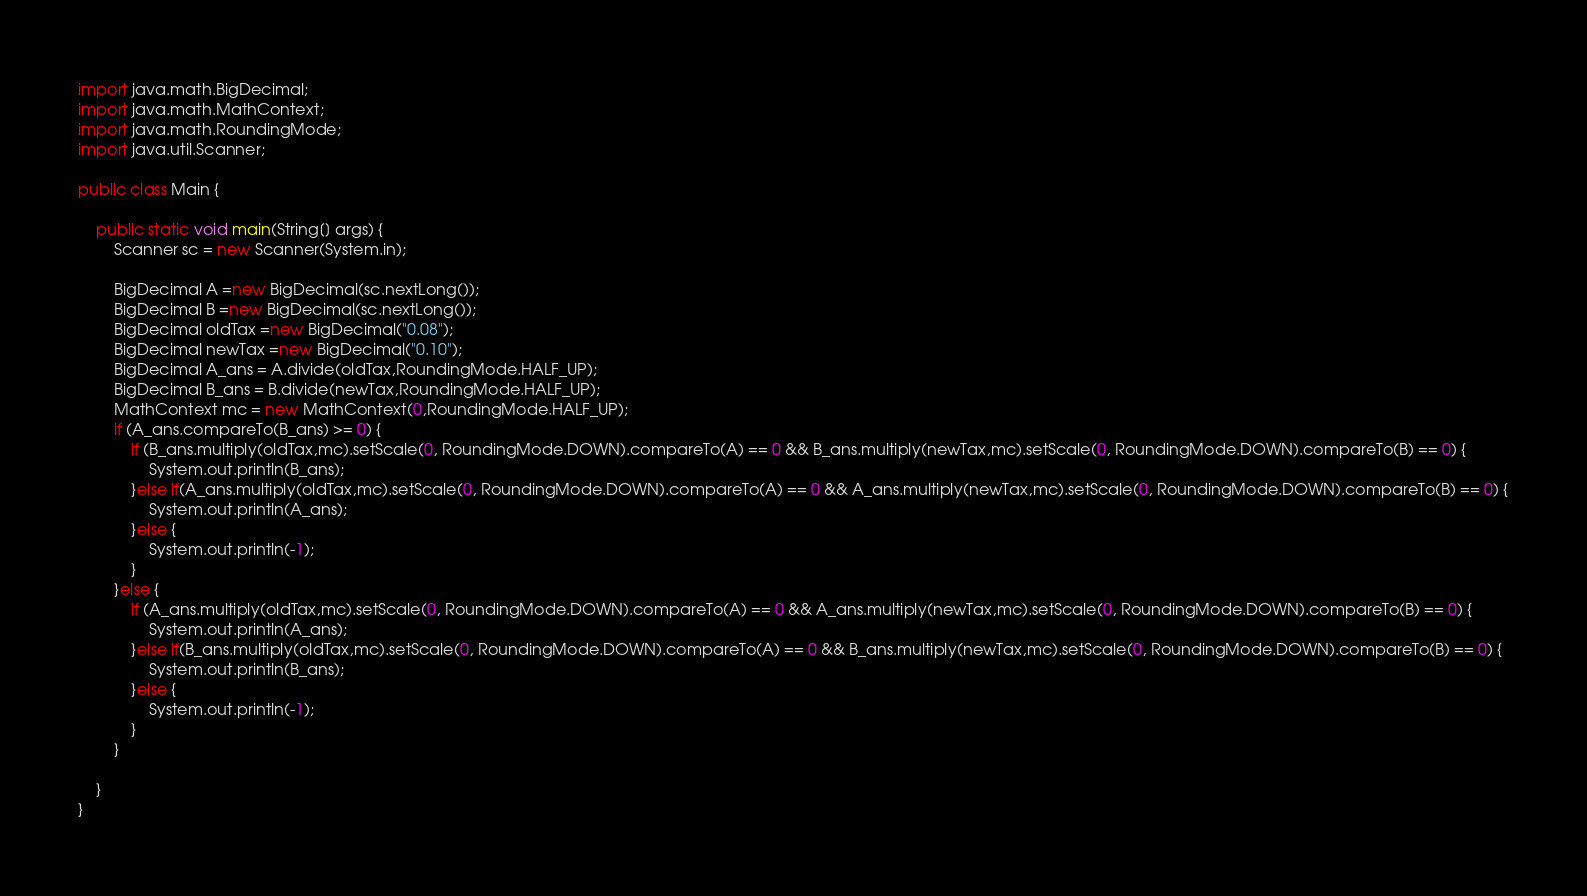<code> <loc_0><loc_0><loc_500><loc_500><_Java_>import java.math.BigDecimal;
import java.math.MathContext;
import java.math.RoundingMode;
import java.util.Scanner;

public class Main {

	public static void main(String[] args) {
		Scanner sc = new Scanner(System.in);

		BigDecimal A =new BigDecimal(sc.nextLong());
		BigDecimal B =new BigDecimal(sc.nextLong());
		BigDecimal oldTax =new BigDecimal("0.08");
		BigDecimal newTax =new BigDecimal("0.10");
		BigDecimal A_ans = A.divide(oldTax,RoundingMode.HALF_UP);
		BigDecimal B_ans = B.divide(newTax,RoundingMode.HALF_UP);
		MathContext mc = new MathContext(0,RoundingMode.HALF_UP);
		if (A_ans.compareTo(B_ans) >= 0) {
			if (B_ans.multiply(oldTax,mc).setScale(0, RoundingMode.DOWN).compareTo(A) == 0 && B_ans.multiply(newTax,mc).setScale(0, RoundingMode.DOWN).compareTo(B) == 0) {
				System.out.println(B_ans);
			}else if(A_ans.multiply(oldTax,mc).setScale(0, RoundingMode.DOWN).compareTo(A) == 0 && A_ans.multiply(newTax,mc).setScale(0, RoundingMode.DOWN).compareTo(B) == 0) {
				System.out.println(A_ans);
			}else {
				System.out.println(-1);
			}
		}else {
			if (A_ans.multiply(oldTax,mc).setScale(0, RoundingMode.DOWN).compareTo(A) == 0 && A_ans.multiply(newTax,mc).setScale(0, RoundingMode.DOWN).compareTo(B) == 0) {
				System.out.println(A_ans);
			}else if(B_ans.multiply(oldTax,mc).setScale(0, RoundingMode.DOWN).compareTo(A) == 0 && B_ans.multiply(newTax,mc).setScale(0, RoundingMode.DOWN).compareTo(B) == 0) {
				System.out.println(B_ans);
			}else {
				System.out.println(-1);
			}
		}

	}
}</code> 